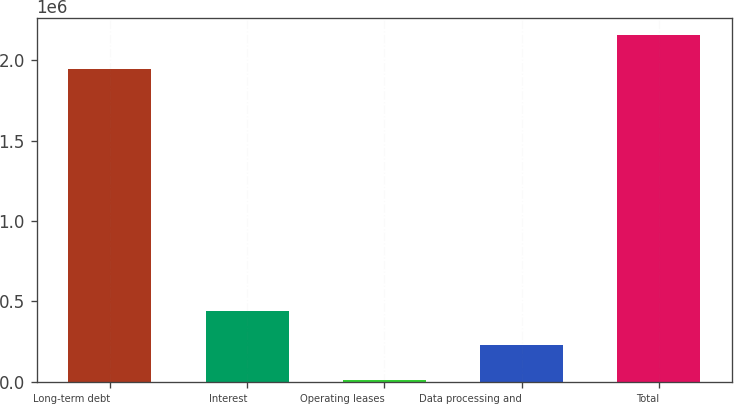Convert chart. <chart><loc_0><loc_0><loc_500><loc_500><bar_chart><fcel>Long-term debt<fcel>Interest<fcel>Operating leases<fcel>Data processing and<fcel>Total<nl><fcel>1.94503e+06<fcel>437919<fcel>14860<fcel>226389<fcel>2.15656e+06<nl></chart> 